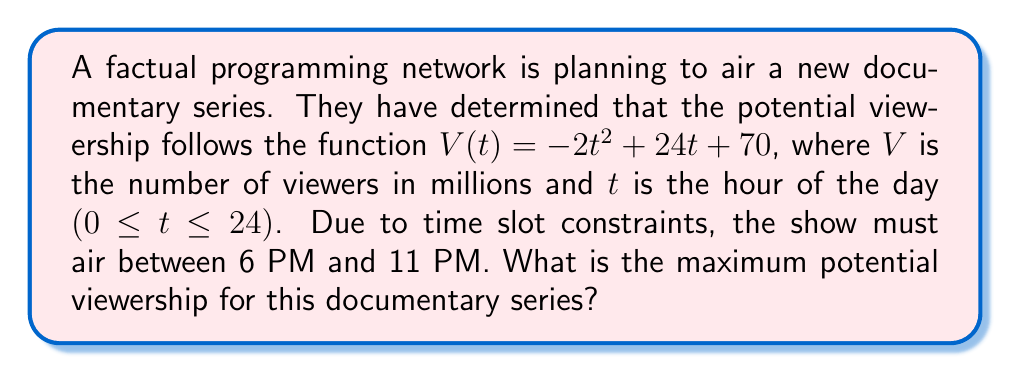Teach me how to tackle this problem. To find the maximum potential viewership, we need to:

1. Identify the domain of interest: $6 \leq t \leq 11$

2. Find the critical points of $V(t)$ by taking the derivative and setting it to zero:
   $$V'(t) = -4t + 24$$
   $$-4t + 24 = 0$$
   $$t = 6$$

3. Evaluate $V(t)$ at the critical point and the endpoints of the domain:
   At $t = 6$: $V(6) = -2(6)^2 + 24(6) + 70 = 214$ million viewers
   At $t = 6$ (endpoint): $V(6) = -2(6)^2 + 24(6) + 70 = 214$ million viewers
   At $t = 11$ (endpoint): $V(11) = -2(11)^2 + 24(11) + 70 = 114$ million viewers

4. Compare the values:
   $V(6) = 214$ million (critical point and endpoint)
   $V(11) = 114$ million (endpoint)

The maximum value occurs at $t = 6$, which is 214 million viewers.
Answer: 214 million viewers 